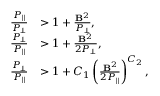Convert formula to latex. <formula><loc_0><loc_0><loc_500><loc_500>\begin{array} { r l } { \frac { P _ { \| } } { P _ { \perp } } } & { > 1 + \frac { B ^ { 2 } } { P _ { \perp } } , } \\ { \frac { P _ { \perp } } { P _ { \| } } } & { > 1 + \frac { B ^ { 2 } } { 2 P _ { \perp } } , } \\ { \frac { P _ { \perp } } { P _ { \| } } } & { > 1 + C _ { 1 } \left ( \frac { B ^ { 2 } } { 2 P _ { \| } } \right ) ^ { C _ { 2 } } , } \end{array}</formula> 